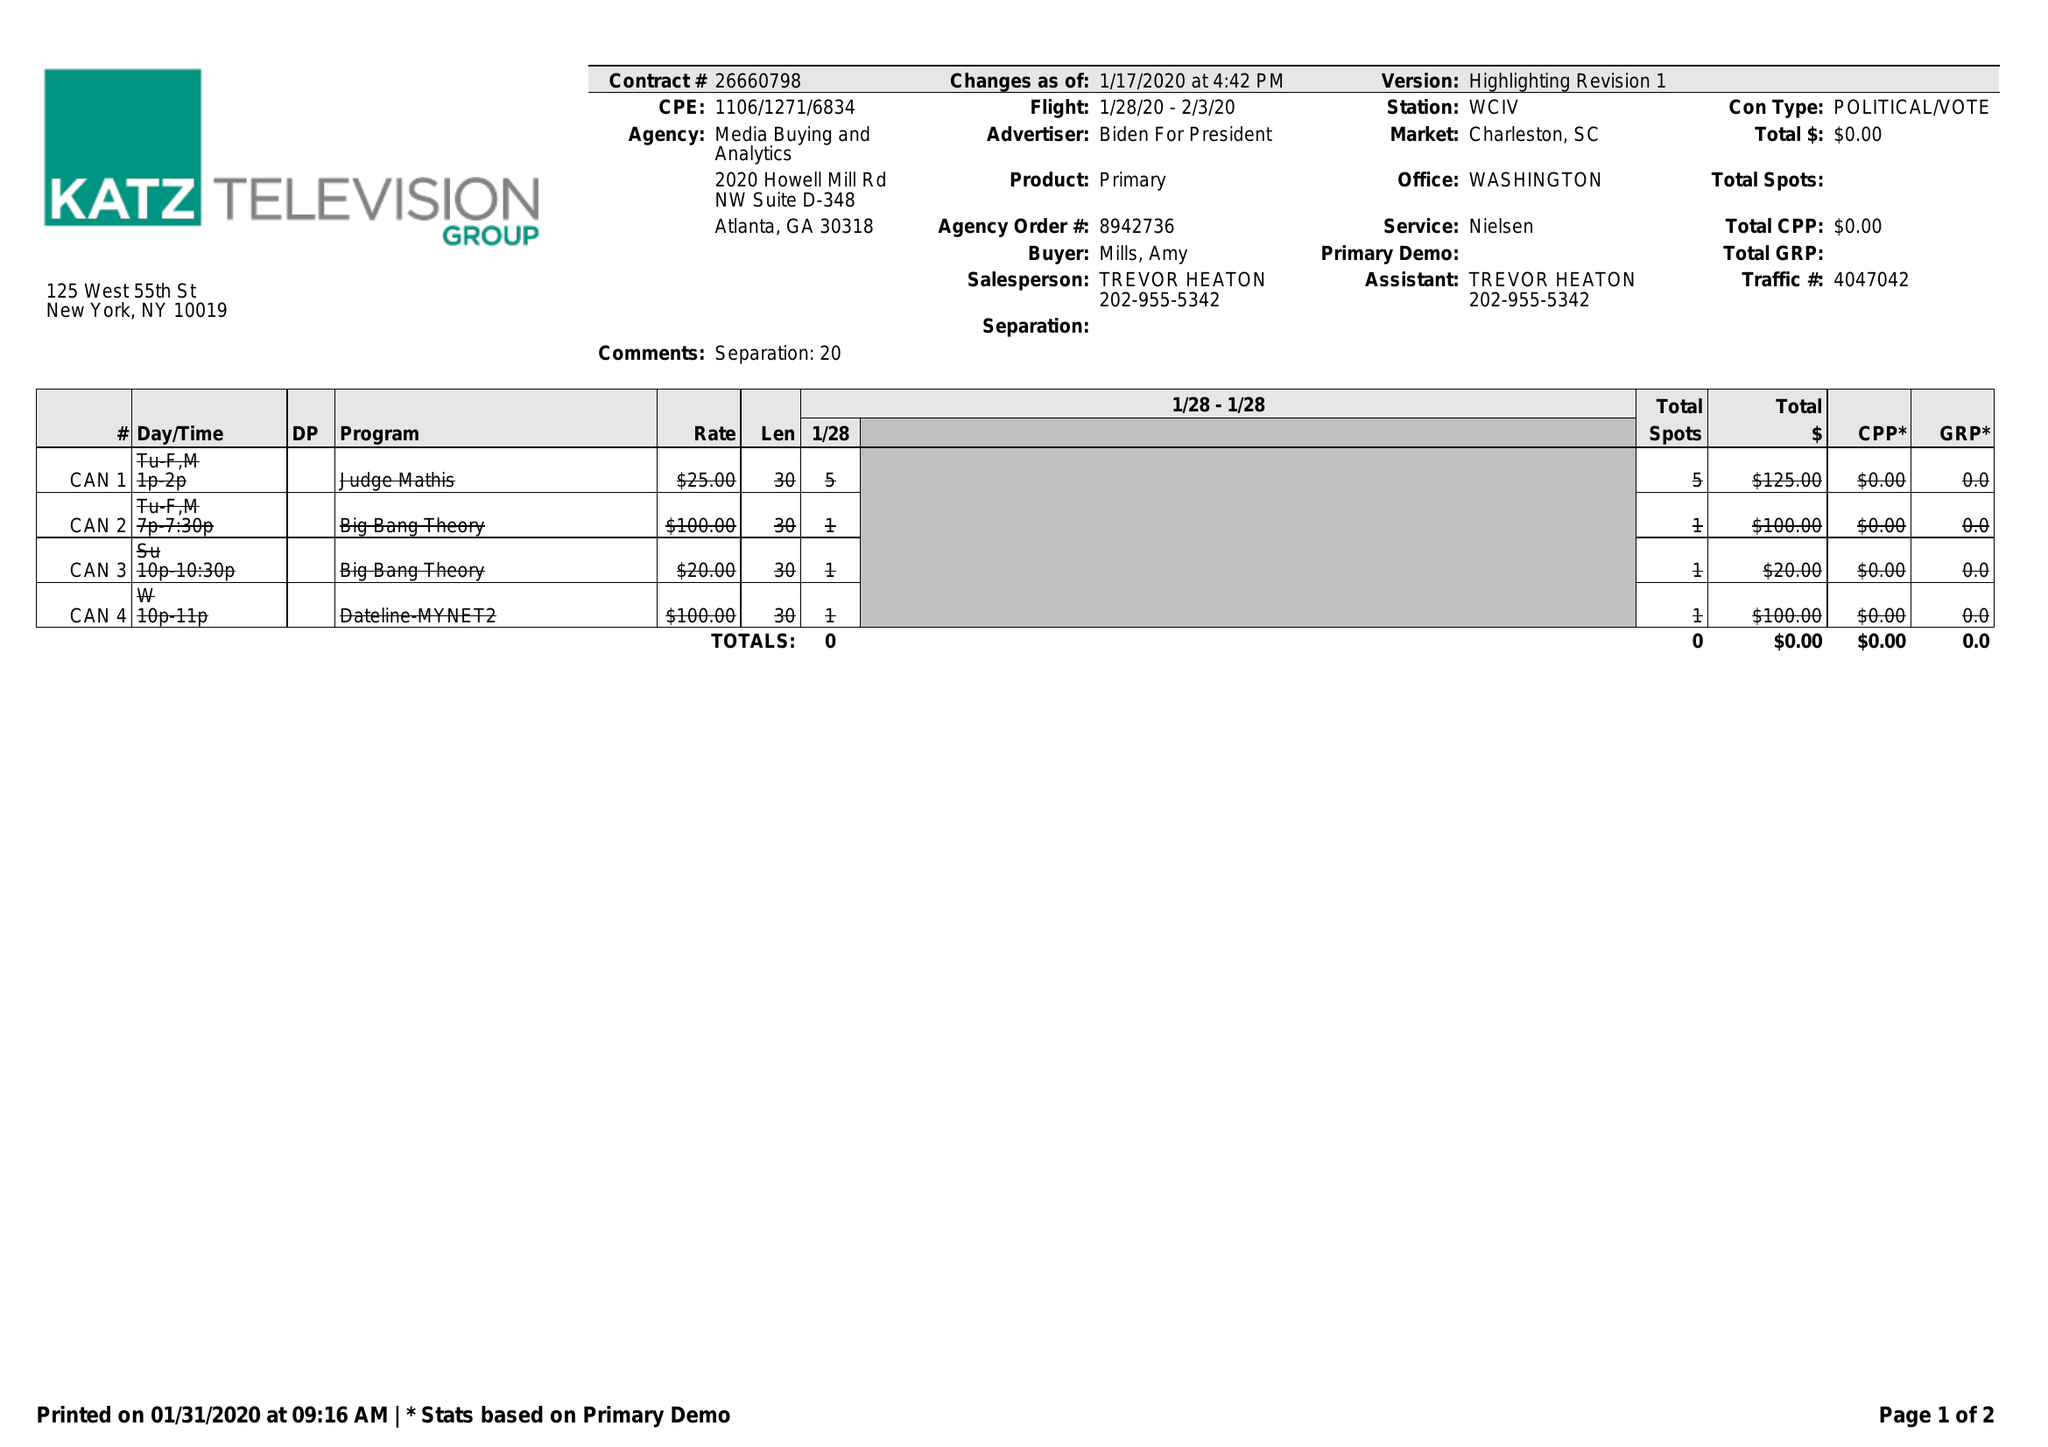What is the value for the contract_num?
Answer the question using a single word or phrase. 26660798 